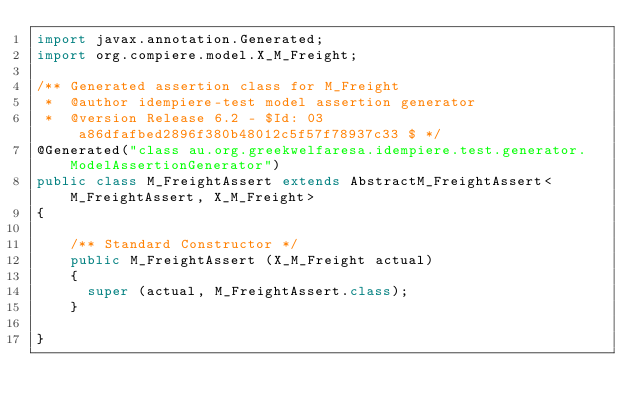<code> <loc_0><loc_0><loc_500><loc_500><_Java_>import javax.annotation.Generated;
import org.compiere.model.X_M_Freight;

/** Generated assertion class for M_Freight
 *  @author idempiere-test model assertion generator
 *  @version Release 6.2 - $Id: 03a86dfafbed2896f380b48012c5f57f78937c33 $ */
@Generated("class au.org.greekwelfaresa.idempiere.test.generator.ModelAssertionGenerator")
public class M_FreightAssert extends AbstractM_FreightAssert<M_FreightAssert, X_M_Freight>
{

    /** Standard Constructor */
    public M_FreightAssert (X_M_Freight actual)
    {
      super (actual, M_FreightAssert.class);
    }

}</code> 